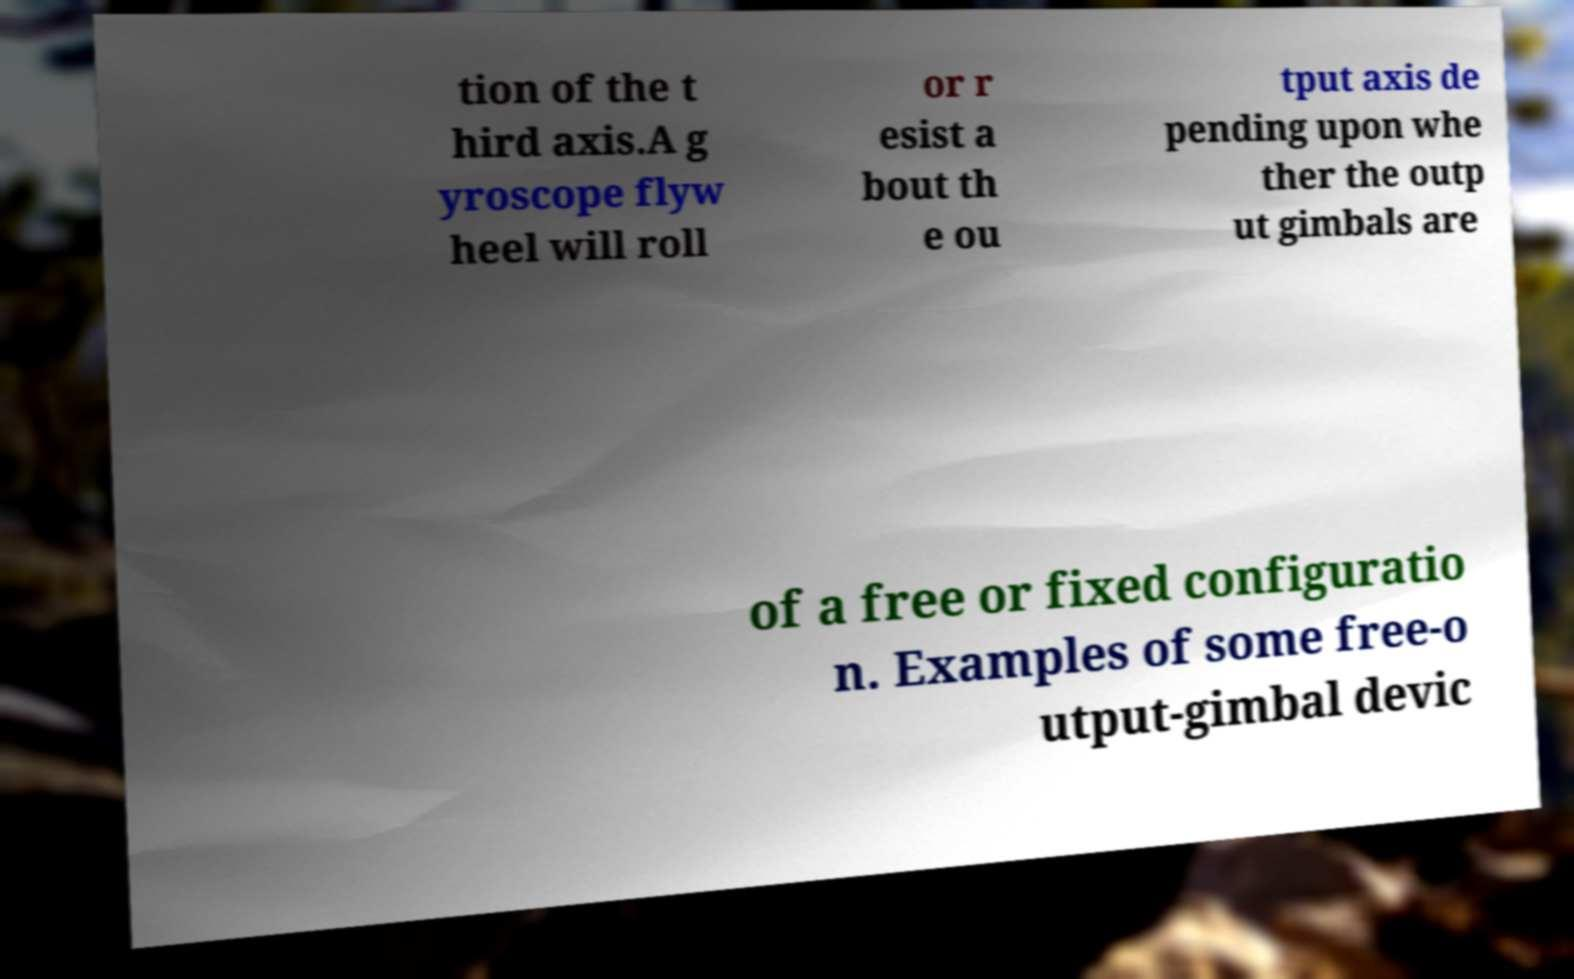What messages or text are displayed in this image? I need them in a readable, typed format. tion of the t hird axis.A g yroscope flyw heel will roll or r esist a bout th e ou tput axis de pending upon whe ther the outp ut gimbals are of a free or fixed configuratio n. Examples of some free-o utput-gimbal devic 